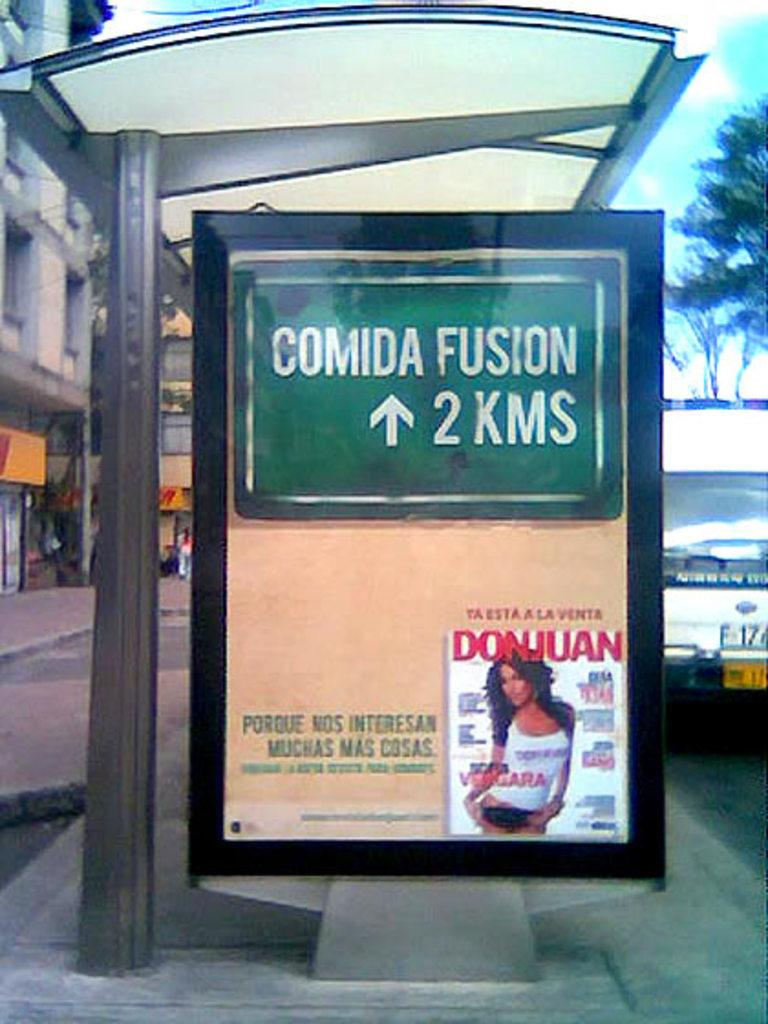<image>
Present a compact description of the photo's key features. Comida fusion 2 kms green sign on a border with a magazine 